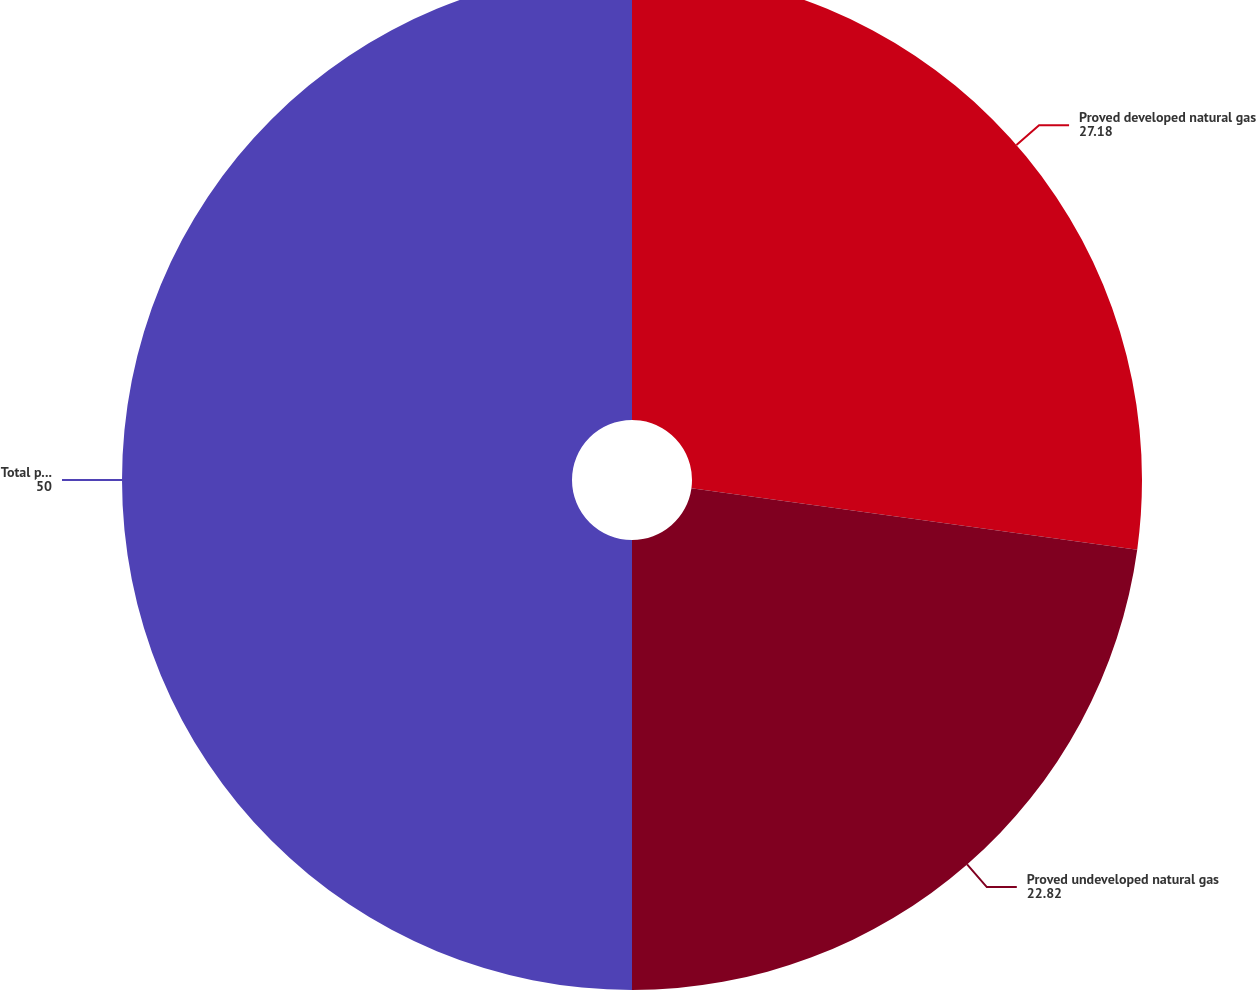Convert chart. <chart><loc_0><loc_0><loc_500><loc_500><pie_chart><fcel>Proved developed natural gas<fcel>Proved undeveloped natural gas<fcel>Total proved natural gas<nl><fcel>27.18%<fcel>22.82%<fcel>50.0%<nl></chart> 